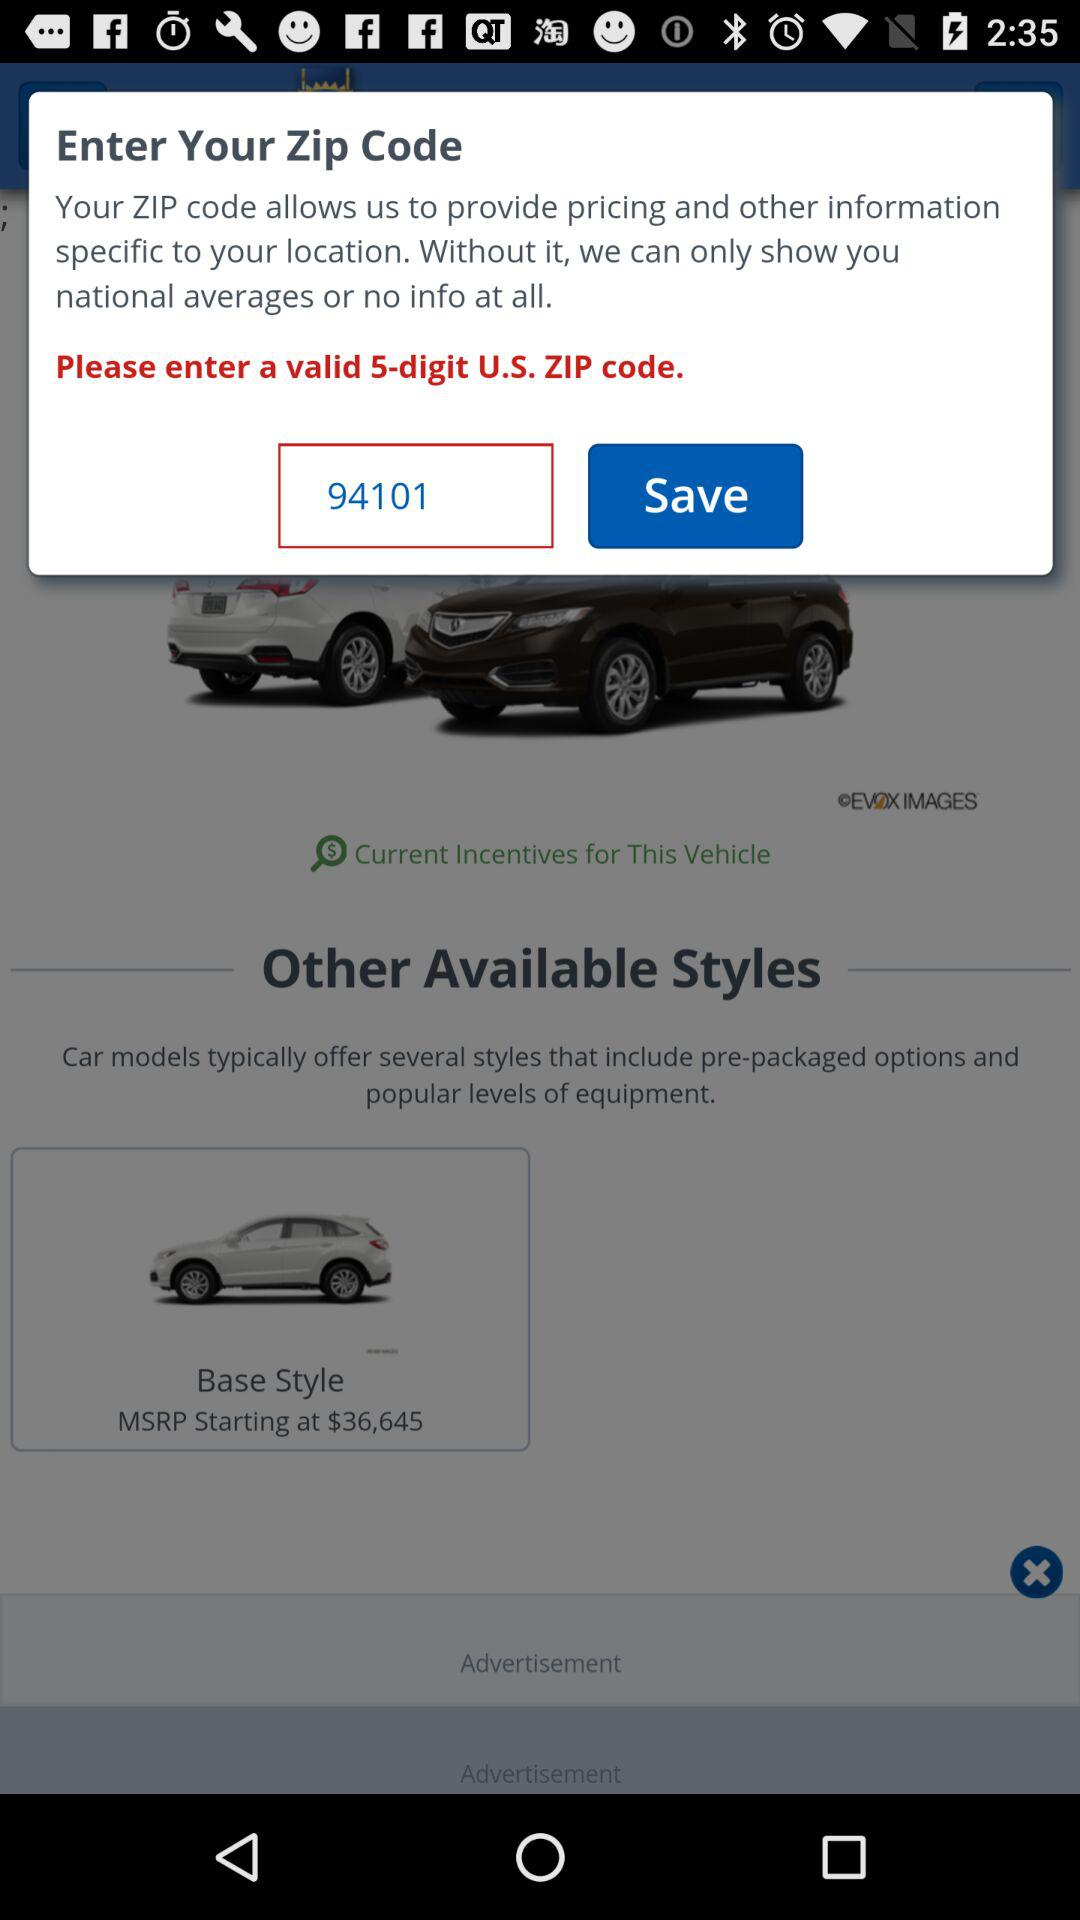What is the zip code? The zip code is 94101. 